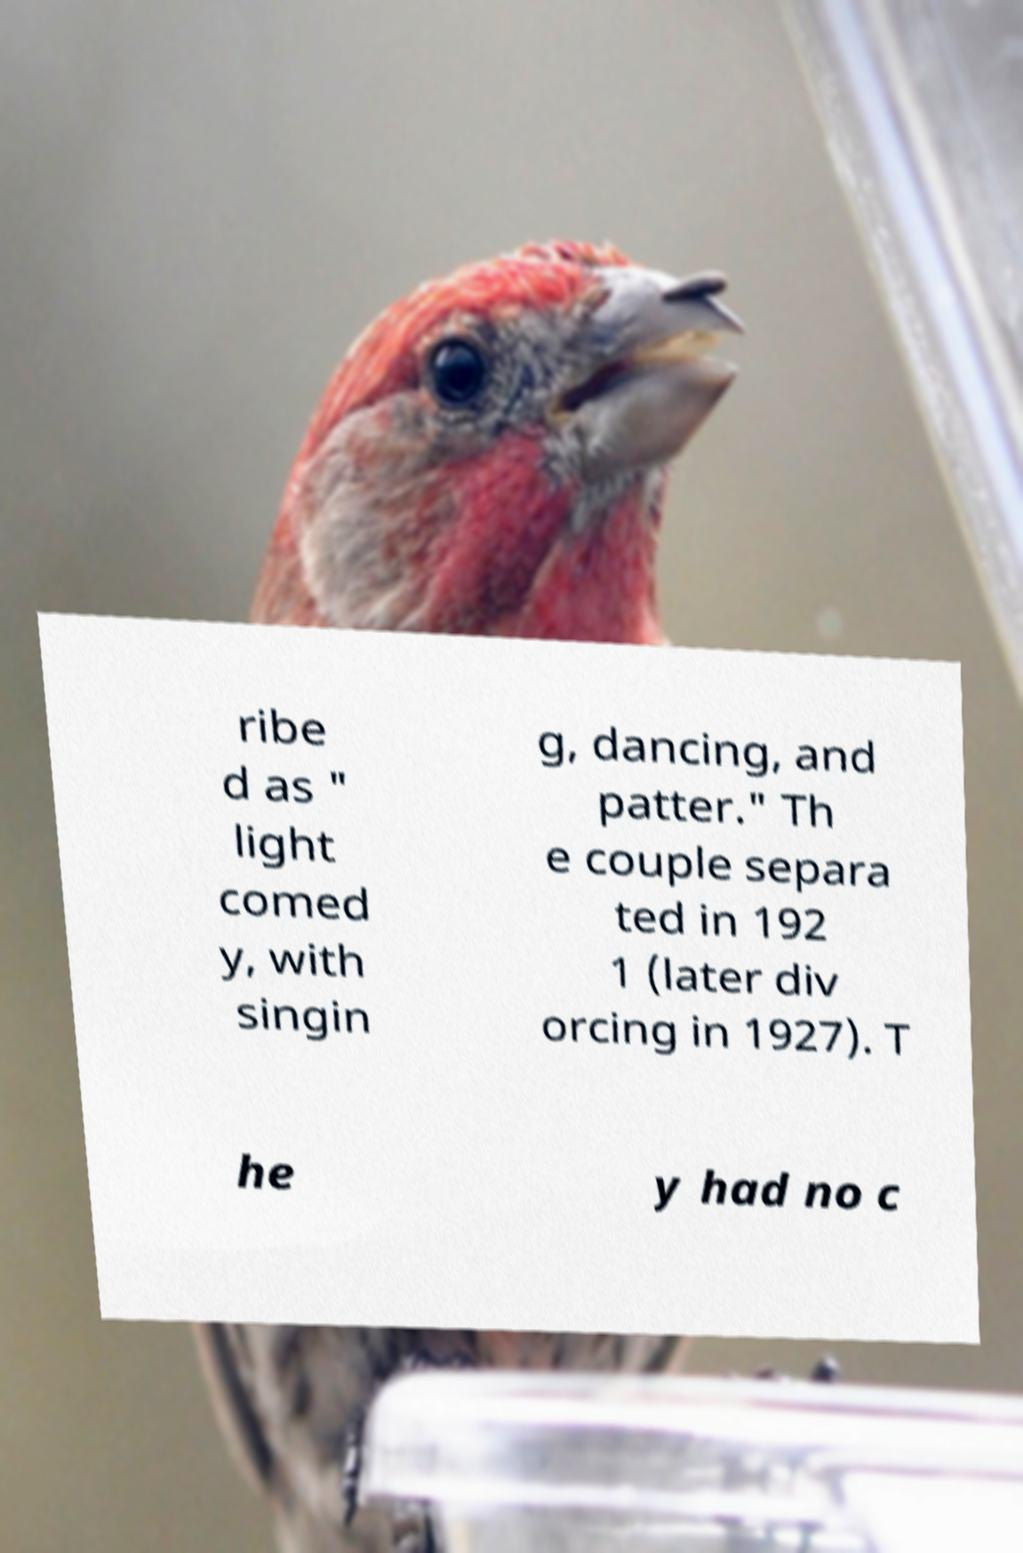Please identify and transcribe the text found in this image. ribe d as " light comed y, with singin g, dancing, and patter." Th e couple separa ted in 192 1 (later div orcing in 1927). T he y had no c 